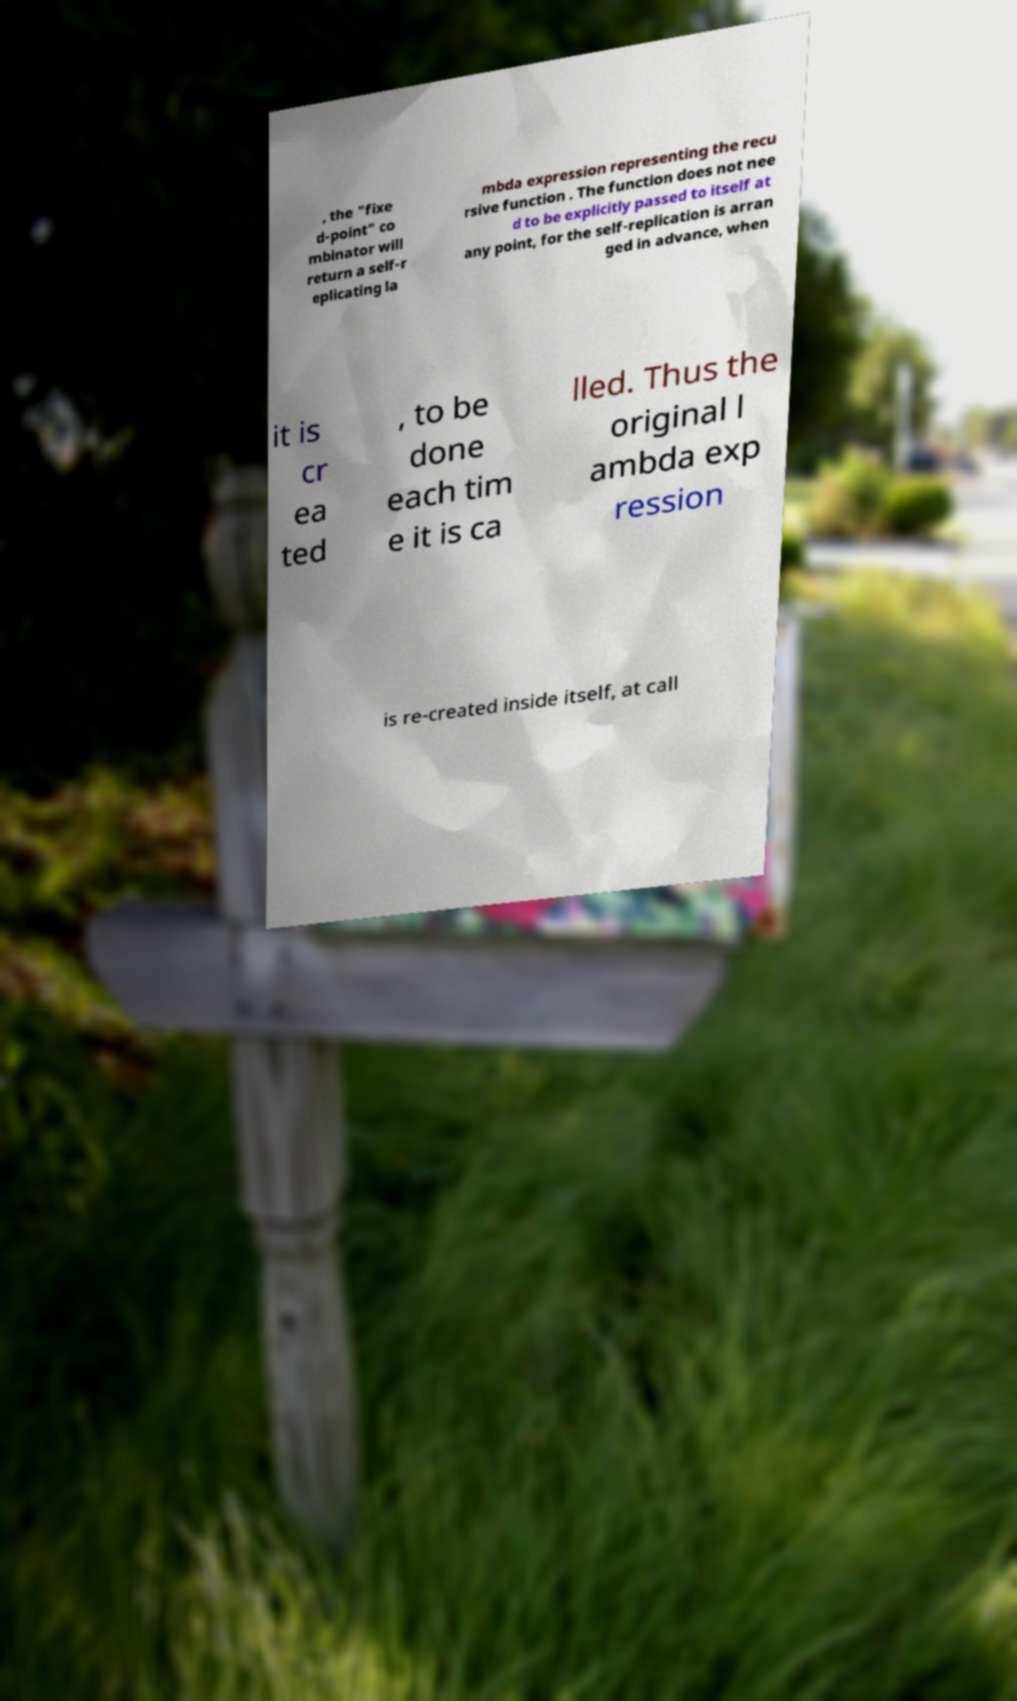There's text embedded in this image that I need extracted. Can you transcribe it verbatim? , the "fixe d-point" co mbinator will return a self-r eplicating la mbda expression representing the recu rsive function . The function does not nee d to be explicitly passed to itself at any point, for the self-replication is arran ged in advance, when it is cr ea ted , to be done each tim e it is ca lled. Thus the original l ambda exp ression is re-created inside itself, at call 